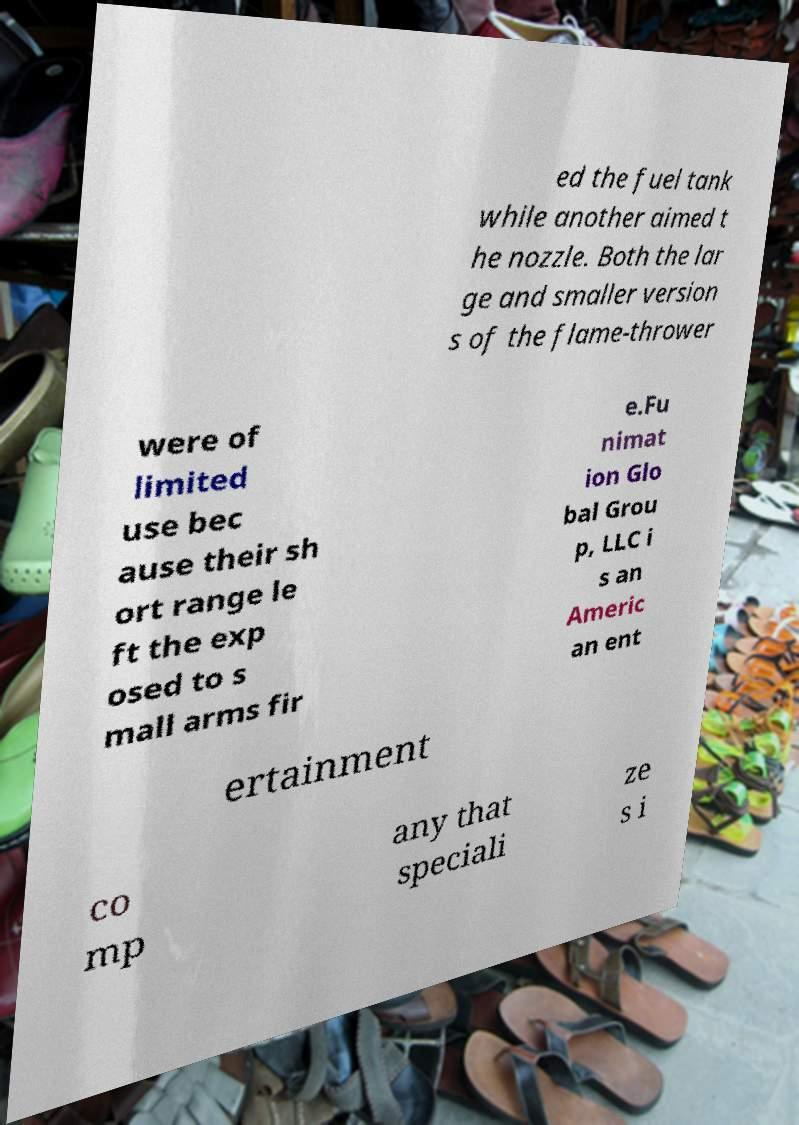I need the written content from this picture converted into text. Can you do that? ed the fuel tank while another aimed t he nozzle. Both the lar ge and smaller version s of the flame-thrower were of limited use bec ause their sh ort range le ft the exp osed to s mall arms fir e.Fu nimat ion Glo bal Grou p, LLC i s an Americ an ent ertainment co mp any that speciali ze s i 